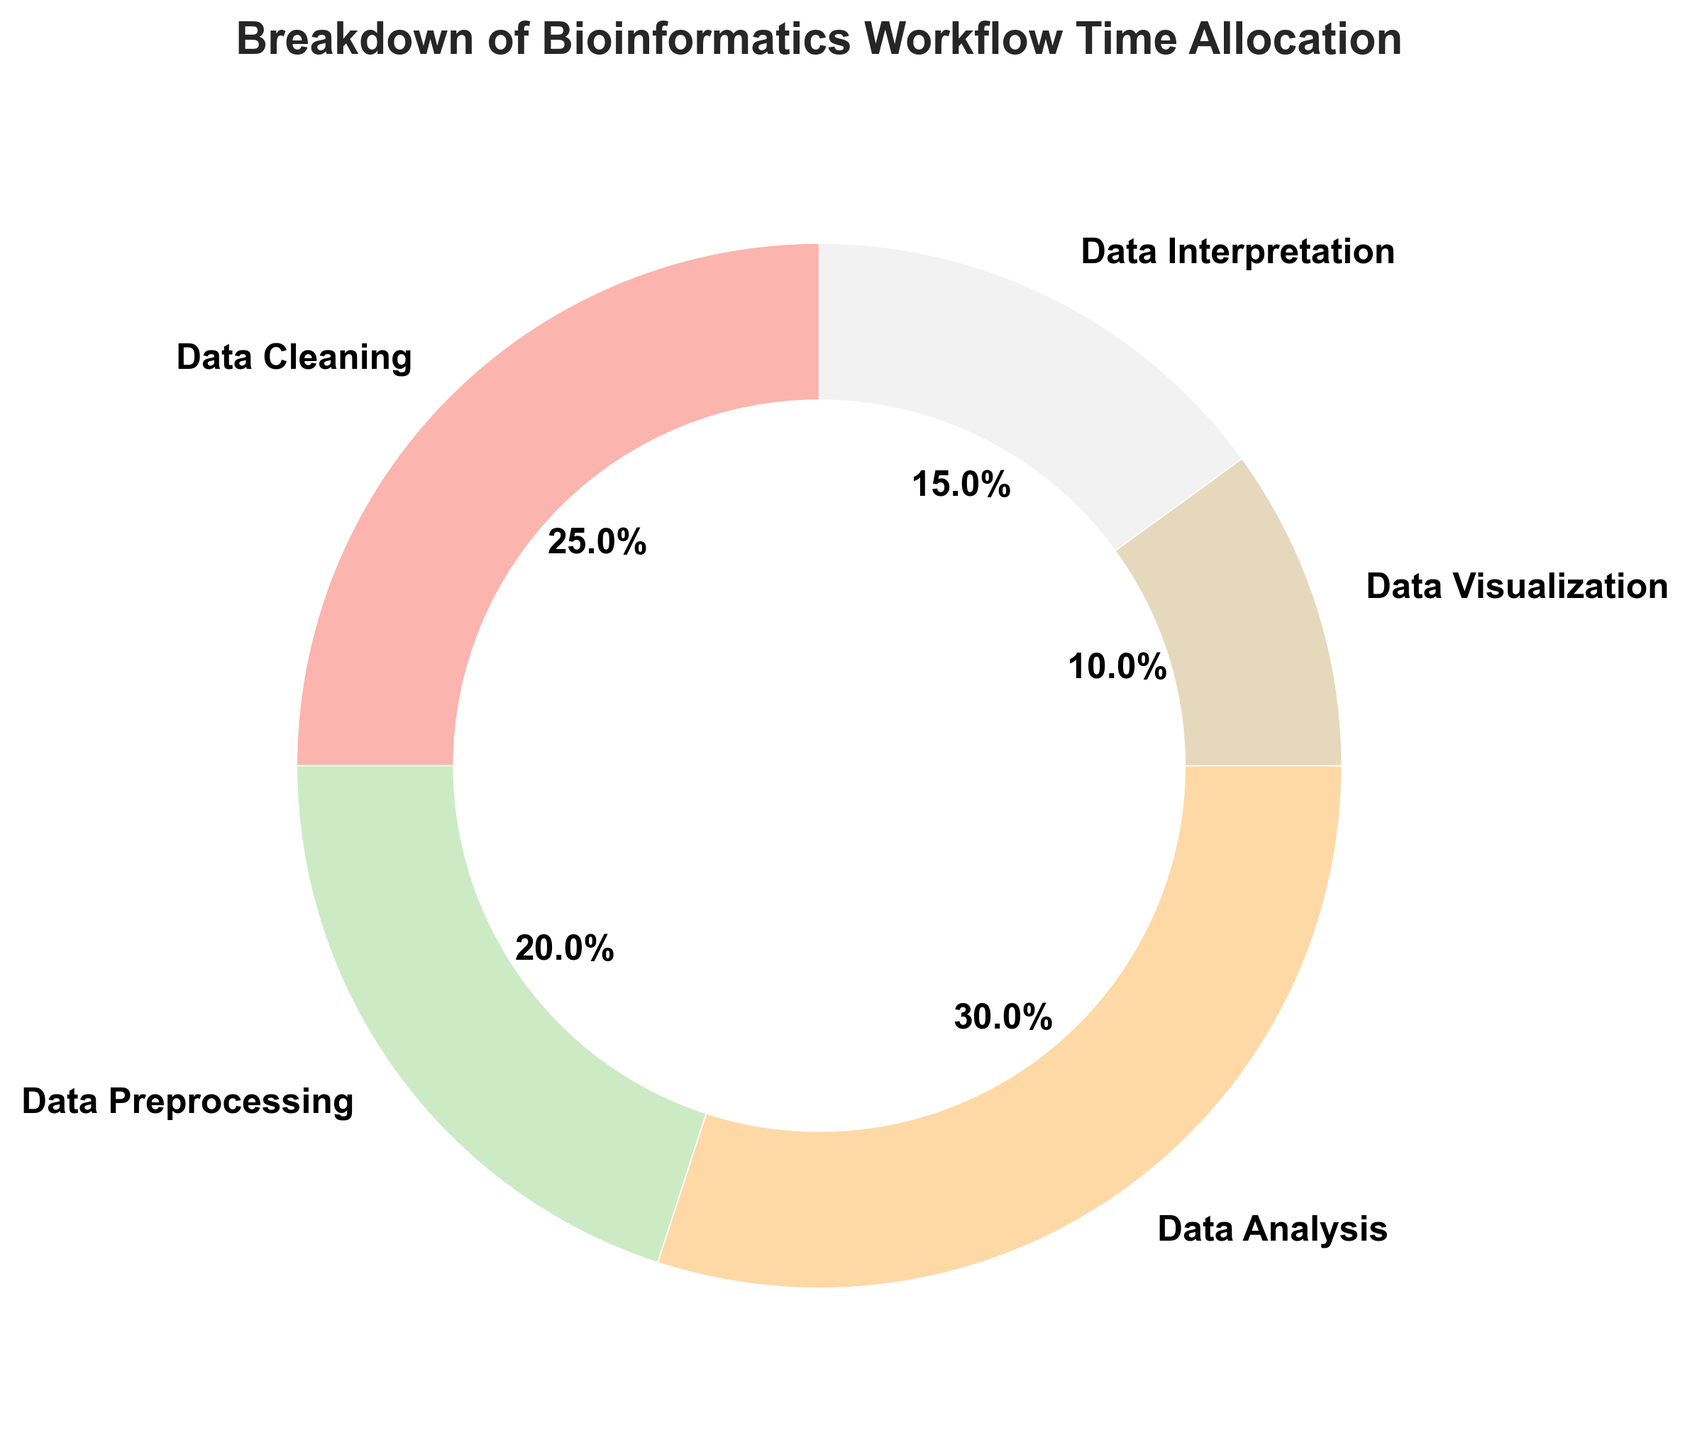What is the category with the highest time allocation? The category with the highest time allocation can be identified by looking at the category with the largest slice in the pie chart. "Data Analysis" has the largest slice.
Answer: Data Analysis What percentage of the time is allocated to Data Cleaning and Data Preprocessing combined? Sum the percentages of Data Cleaning (25%) and Data Preprocessing (20%). 25% + 20% = 45%
Answer: 45% How much more time is allocated to Data Analysis compared to Data Visualization? The time allocation for Data Analysis is 30 hours, and for Data Visualization, it is 10 hours. The difference is calculated by subtracting the smaller value from the larger value: 30 - 10 = 20 hours
Answer: 20 hours Which category has the smallest time allocation? The smallest segment of the pie chart represents the smallest time allocation. "Data Visualization" is the smallest segment, with 10 hours.
Answer: Data Visualization Is the time allocated to Data Interpretation greater than the time allocated to Data Preprocessing? The time allocated to Data Interpretation is 15 hours, and the time allocated to Data Preprocessing is 20 hours. Since 15 is less than 20, Data Interpretation has less time allocated.
Answer: No What is the ratio of time allocation between Data Analysis and Data Cleaning? The time allocation for Data Analysis is 30 hours, and for Data Cleaning, it is 25 hours. The ratio is calculated by dividing the time allocated to Data Analysis by the time allocated to Data Cleaning: 30 / 25 = 1.2
Answer: 1.2 How many hours in total are allocated to tasks related to visual representation and interpretation? Sum the hours allocated to Data Visualization (10 hours) and Data Interpretation (15 hours). 10 + 15 = 25 hours
Answer: 25 hours Which category has a time allocation that is exactly equal to the average time allocated per category? First, calculate the average time allocation by summing all allocations and then dividing by the number of categories: (25 + 20 + 30 + 10 + 15) / 5 = 100 / 5 = 20 hours. The category with 20 hours is Data Preprocessing.
Answer: Data Preprocessing If the time allocated to Data Cleaning increased by 5 hours, what would be its new percentage in the pie chart? The new time allocation for Data Cleaning would be 25 + 5 = 30 hours. The new total for all categories would be 100 + 5 = 105 hours. The new percentage is calculated as (30 / 105) * 100% ≈ 28.57%
Answer: 28.57% Which category(ies) occupy the same segment hue as Data Cleaning? By observing the colors of the pie chart wedges, anyone matching Data Cleaning's pastel tone will occupy the same segment. Without specific colors to analyze, this question expects awareness of visual distinctiveness. Based on common plot expectations, there could be no exact matches.
Answer: None (Expected) 